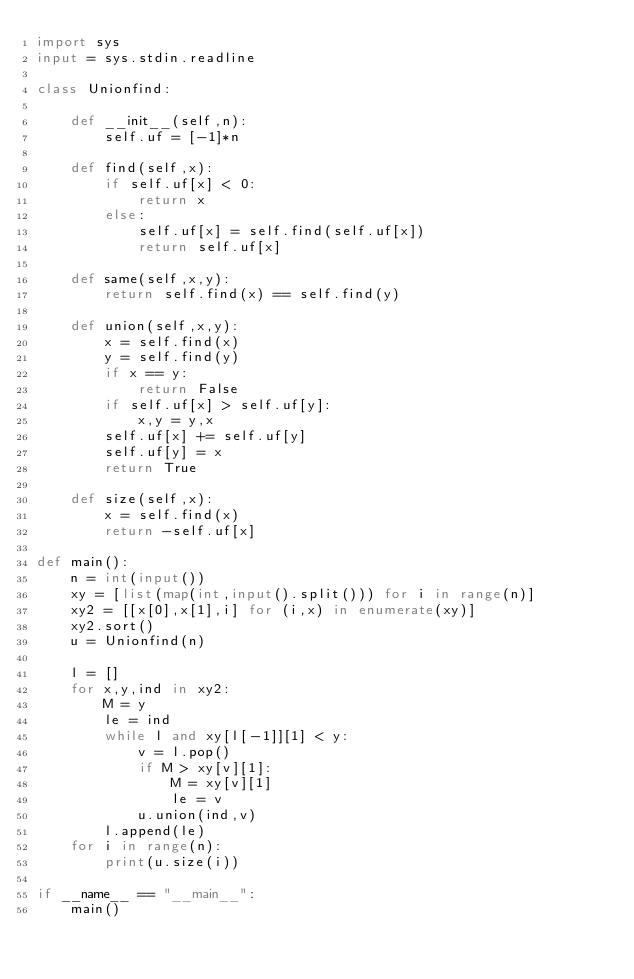Convert code to text. <code><loc_0><loc_0><loc_500><loc_500><_Python_>import sys
input = sys.stdin.readline

class Unionfind:
     
    def __init__(self,n):
        self.uf = [-1]*n
 
    def find(self,x):
        if self.uf[x] < 0:
            return x
        else:
            self.uf[x] = self.find(self.uf[x])
            return self.uf[x]
 
    def same(self,x,y):
        return self.find(x) == self.find(y)
 
    def union(self,x,y):
        x = self.find(x)
        y = self.find(y)
        if x == y:
            return False
        if self.uf[x] > self.uf[y]:
            x,y = y,x
        self.uf[x] += self.uf[y]
        self.uf[y] = x
        return True
 
    def size(self,x):
        x = self.find(x)
        return -self.uf[x]

def main():
    n = int(input())
    xy = [list(map(int,input().split())) for i in range(n)]
    xy2 = [[x[0],x[1],i] for (i,x) in enumerate(xy)]
    xy2.sort()
    u = Unionfind(n)

    l = []
    for x,y,ind in xy2:
        M = y
        le = ind
        while l and xy[l[-1]][1] < y:
            v = l.pop()
            if M > xy[v][1]:
                M = xy[v][1]
                le = v
            u.union(ind,v)
        l.append(le)
    for i in range(n):
        print(u.size(i))

if __name__ == "__main__":
    main()</code> 